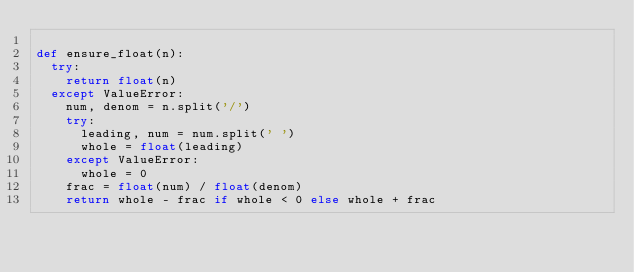<code> <loc_0><loc_0><loc_500><loc_500><_Python_>
def ensure_float(n):
  try:
    return float(n)
  except ValueError:
    num, denom = n.split('/')
    try:
      leading, num = num.split(' ')
      whole = float(leading)
    except ValueError:
      whole = 0
    frac = float(num) / float(denom)
    return whole - frac if whole < 0 else whole + frac
</code> 